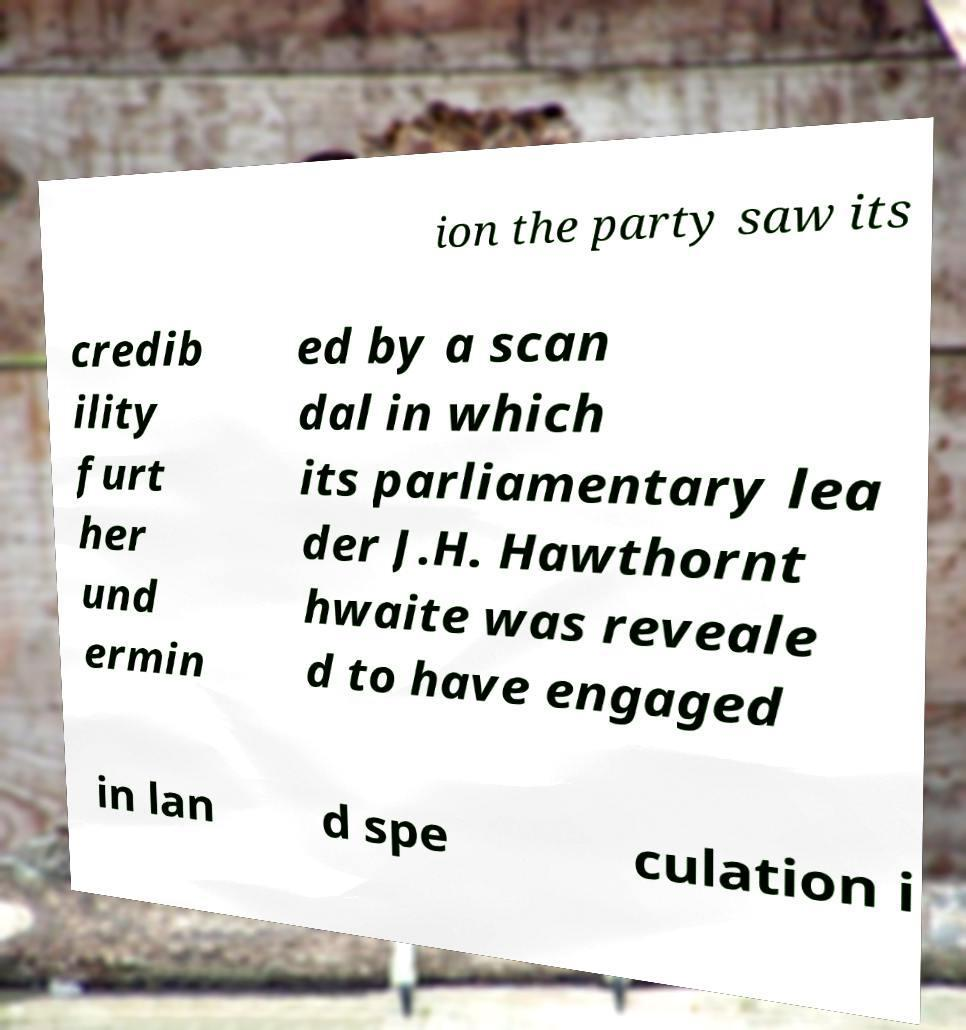Can you read and provide the text displayed in the image?This photo seems to have some interesting text. Can you extract and type it out for me? ion the party saw its credib ility furt her und ermin ed by a scan dal in which its parliamentary lea der J.H. Hawthornt hwaite was reveale d to have engaged in lan d spe culation i 